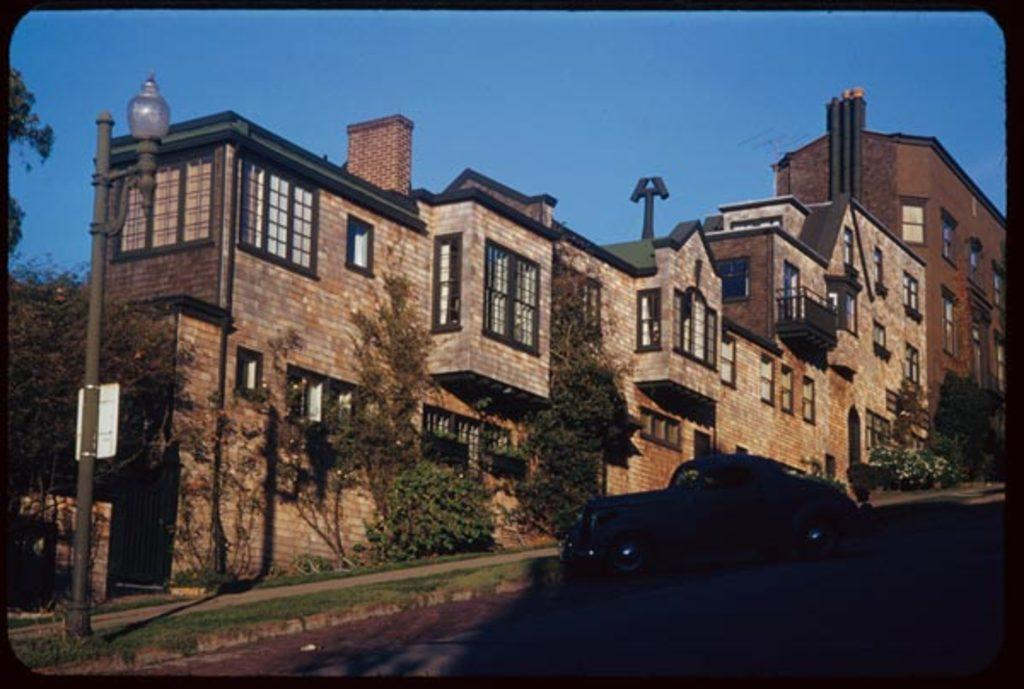What vehicle is located on the right side of the image? There is a car on the right side of the image. What can be seen in the middle of the image? There are trees and buildings in the middle of the image. What type of street fixture is on the left side of the image? There is a streetlamp on the left side of the image. What is visible at the top of the image? The sky is visible at the top of the image. What type of team is playing in the image? There is no team present in the image; it features a car, trees, buildings, a streetlamp, and the sky. Is there a scarf wrapped around the streetlamp in the image? There is no scarf present in the image; only the streetlamp is visible. 